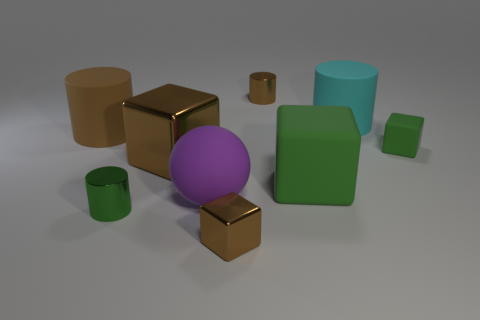There is a big object that is the same color as the small matte block; what is its shape?
Your response must be concise. Cube. What material is the big green thing?
Provide a short and direct response. Rubber. Are the green cylinder and the large cyan cylinder made of the same material?
Give a very brief answer. No. How many matte things are big purple spheres or small green objects?
Give a very brief answer. 2. What shape is the green thing in front of the big green object?
Your response must be concise. Cylinder. What is the size of the other block that is made of the same material as the small brown cube?
Make the answer very short. Large. What shape is the large rubber thing that is both in front of the small green matte cube and to the left of the tiny brown shiny cylinder?
Provide a succinct answer. Sphere. Do the matte cube behind the large green rubber block and the large metal object have the same color?
Ensure brevity in your answer.  No. Is the shape of the small brown thing in front of the big brown rubber thing the same as the large purple rubber object that is left of the cyan matte object?
Provide a succinct answer. No. There is a rubber cylinder that is on the left side of the small brown shiny cylinder; what is its size?
Your response must be concise. Large. 